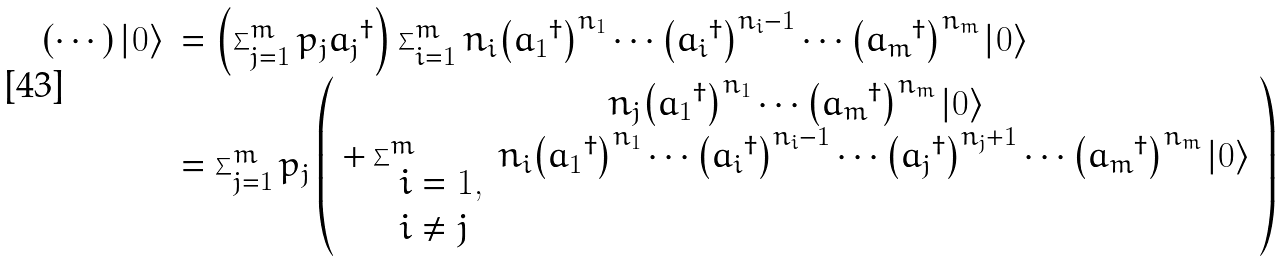Convert formula to latex. <formula><loc_0><loc_0><loc_500><loc_500>\begin{array} { r l } \left ( \cdots \right ) \left | 0 \right \rangle & = \left ( \sum _ { j = 1 } ^ { m } p _ { j } { a _ { j } } ^ { \dagger } \right ) \sum _ { i = 1 } ^ { m } n _ { i } { \left ( { a _ { 1 } } ^ { \dagger } \right ) } ^ { n _ { 1 } } \cdots { \left ( { a _ { i } } ^ { \dagger } \right ) } ^ { n _ { i } - 1 } \cdots { \left ( { a _ { m } } ^ { \dagger } \right ) } ^ { n _ { m } } \left | 0 \right \rangle \\ & = \sum _ { j = 1 } ^ { m } p _ { j } \left ( \begin{array} { c } n _ { j } { \left ( { a _ { 1 } } ^ { \dagger } \right ) } ^ { n _ { 1 } } \cdots { \left ( { a _ { m } } ^ { \dagger } \right ) } ^ { n _ { m } } \left | 0 \right \rangle \\ + \sum _ { \begin{array} { l } i = 1 , \\ i \neq j \end{array} } ^ { m } n _ { i } { \left ( { a _ { 1 } } ^ { \dagger } \right ) } ^ { n _ { 1 } } \cdots { \left ( { a _ { i } } ^ { \dagger } \right ) } ^ { n _ { i } - 1 } \cdots { \left ( { a _ { j } } ^ { \dagger } \right ) } ^ { n _ { j } + 1 } \cdots { \left ( { a _ { m } } ^ { \dagger } \right ) } ^ { n _ { m } } \left | 0 \right \rangle \end{array} \right ) \end{array}</formula> 